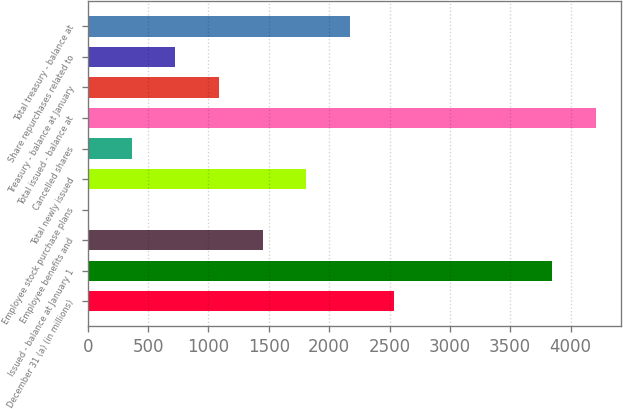<chart> <loc_0><loc_0><loc_500><loc_500><bar_chart><fcel>December 31 (a) (in millions)<fcel>Issued - balance at January 1<fcel>Employee benefits and<fcel>Employee stock purchase plans<fcel>Total newly issued<fcel>Cancelled shares<fcel>Total issued - balance at<fcel>Treasury - balance at January<fcel>Share repurchases related to<fcel>Total treasury - balance at<nl><fcel>2533.16<fcel>3848.38<fcel>1448.12<fcel>1.4<fcel>1809.8<fcel>363.08<fcel>4210.06<fcel>1086.44<fcel>724.76<fcel>2171.48<nl></chart> 